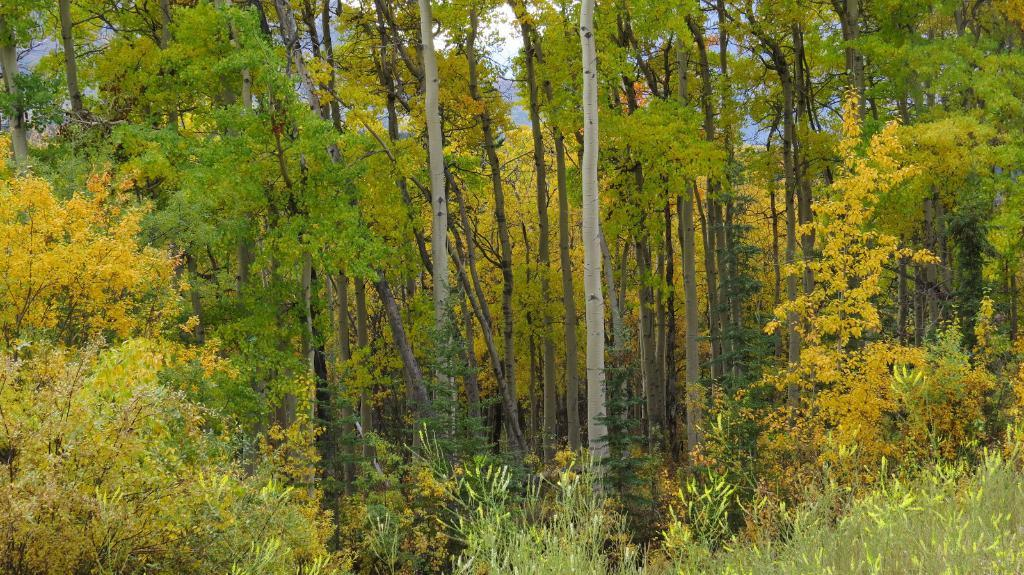What type of living organisms can be seen in the image? Plants with flowers are visible in the image. What can be seen in the background of the image? There are trees in the background of the image. What is visible in the sky? Clouds and a blue sky are visible in the image. How many chairs can be seen in the image? There are no chairs present in the image. Is there a boat visible in the image? There is no boat present in the image. 